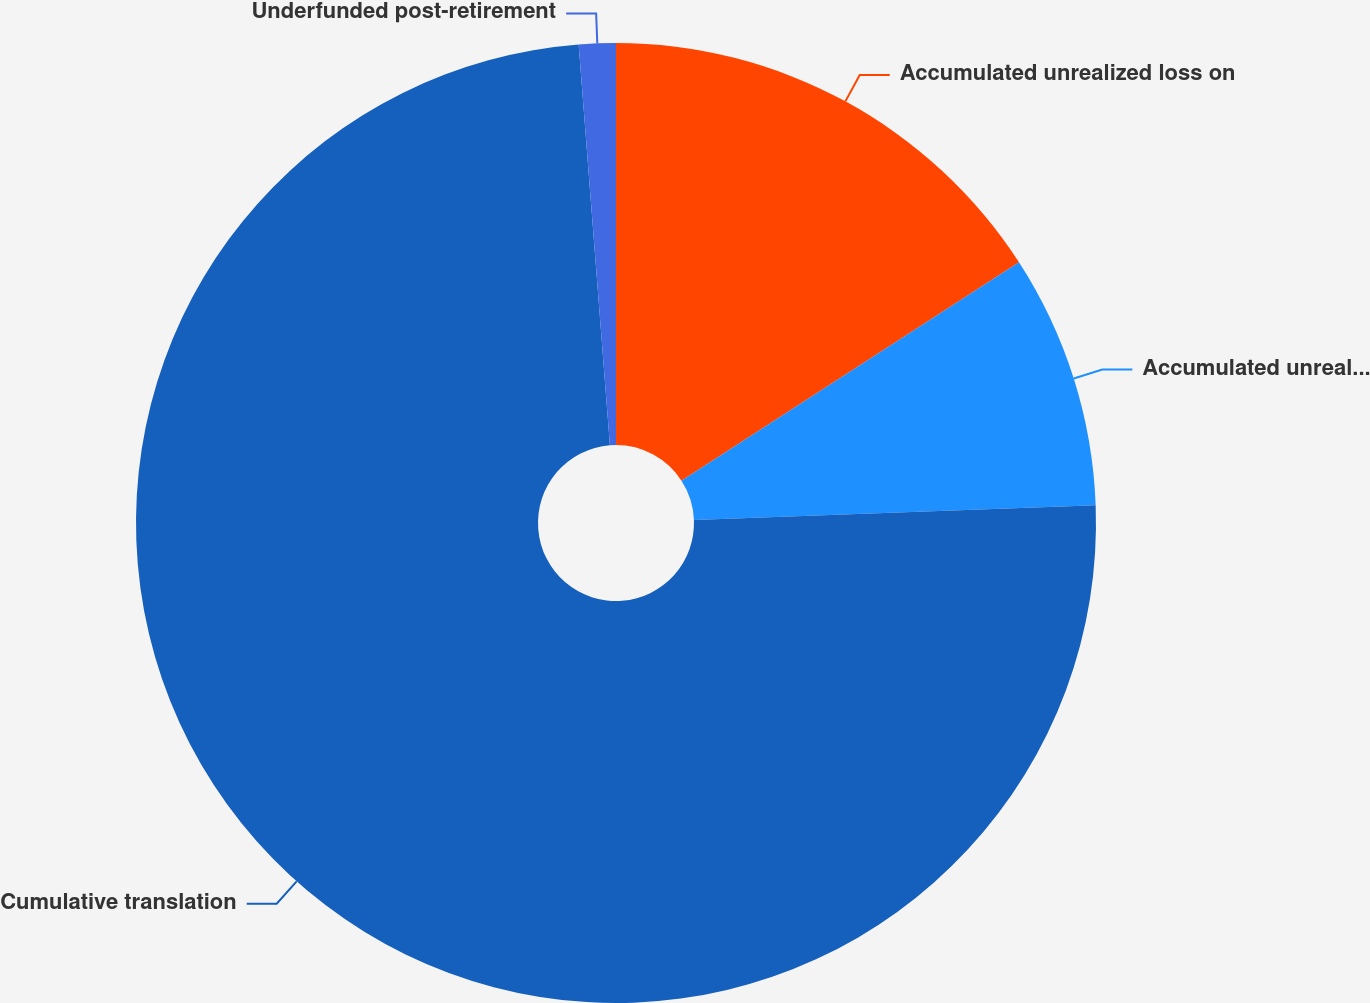<chart> <loc_0><loc_0><loc_500><loc_500><pie_chart><fcel>Accumulated unrealized loss on<fcel>Accumulated unrealized gain<fcel>Cumulative translation<fcel>Underfunded post-retirement<nl><fcel>15.86%<fcel>8.55%<fcel>74.35%<fcel>1.24%<nl></chart> 